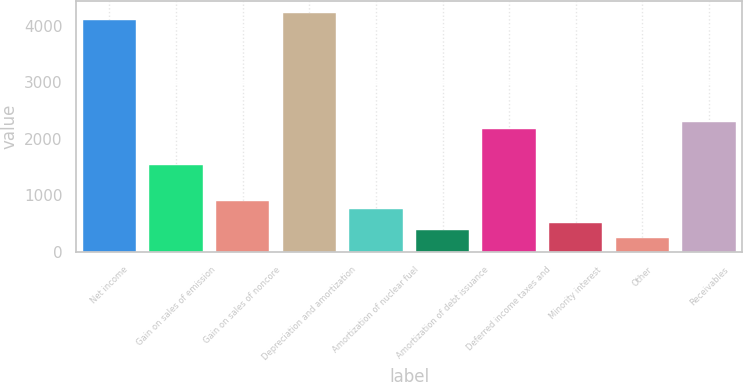<chart> <loc_0><loc_0><loc_500><loc_500><bar_chart><fcel>Net income<fcel>Gain on sales of emission<fcel>Gain on sales of noncore<fcel>Depreciation and amortization<fcel>Amortization of nuclear fuel<fcel>Amortization of debt issuance<fcel>Deferred income taxes and<fcel>Minority interest<fcel>Other<fcel>Receivables<nl><fcel>4090.6<fcel>1534.6<fcel>895.6<fcel>4218.4<fcel>767.8<fcel>384.4<fcel>2173.6<fcel>512.2<fcel>256.6<fcel>2301.4<nl></chart> 